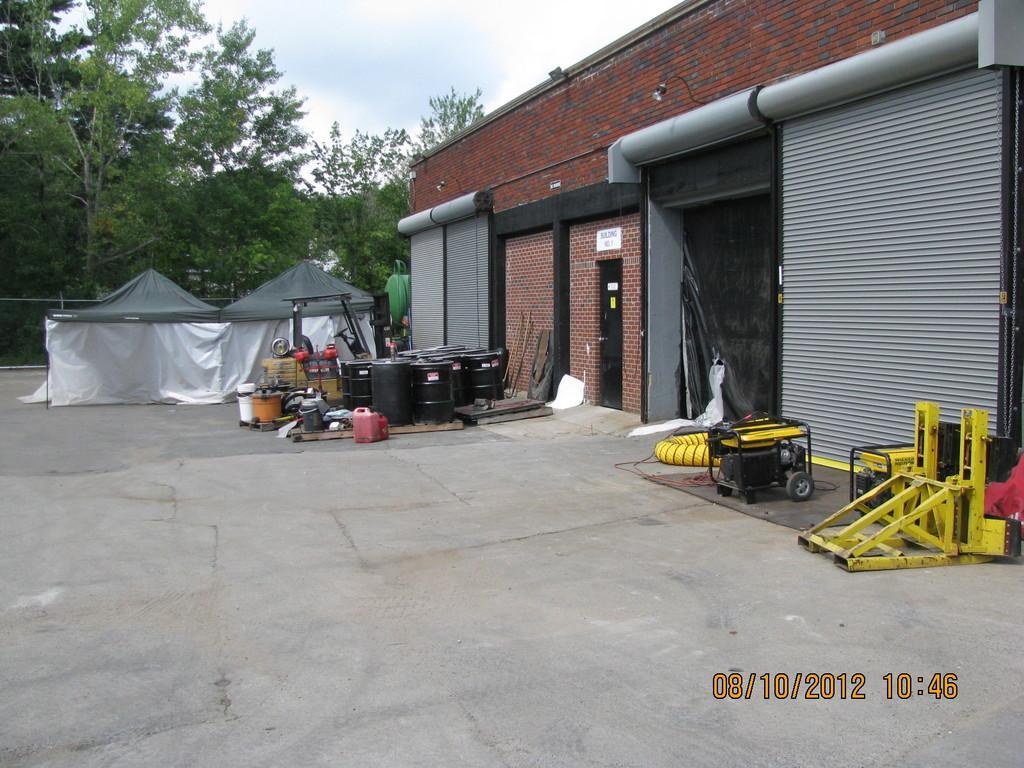Could you give a brief overview of what you see in this image? In this image I can see the building which is in brown and grey color. In-front of the building I can see many containers, cans and the metal rods which are in yellow color. To the left I can see some tents. In the back there are many trees, clouds and the sky. 